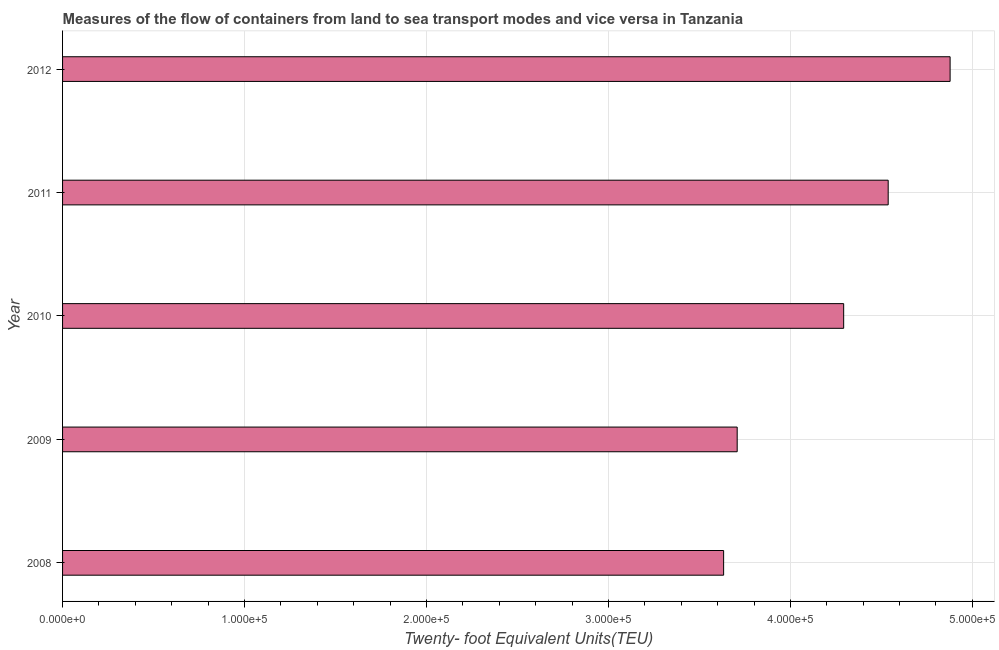Does the graph contain any zero values?
Ensure brevity in your answer.  No. Does the graph contain grids?
Offer a very short reply. Yes. What is the title of the graph?
Provide a short and direct response. Measures of the flow of containers from land to sea transport modes and vice versa in Tanzania. What is the label or title of the X-axis?
Your response must be concise. Twenty- foot Equivalent Units(TEU). What is the label or title of the Y-axis?
Your answer should be very brief. Year. What is the container port traffic in 2011?
Provide a succinct answer. 4.54e+05. Across all years, what is the maximum container port traffic?
Offer a terse response. 4.88e+05. Across all years, what is the minimum container port traffic?
Keep it short and to the point. 3.63e+05. In which year was the container port traffic maximum?
Provide a succinct answer. 2012. In which year was the container port traffic minimum?
Your response must be concise. 2008. What is the sum of the container port traffic?
Keep it short and to the point. 2.10e+06. What is the difference between the container port traffic in 2010 and 2011?
Offer a very short reply. -2.45e+04. What is the average container port traffic per year?
Your answer should be very brief. 4.21e+05. What is the median container port traffic?
Make the answer very short. 4.29e+05. In how many years, is the container port traffic greater than 300000 TEU?
Ensure brevity in your answer.  5. Do a majority of the years between 2009 and 2010 (inclusive) have container port traffic greater than 160000 TEU?
Your answer should be compact. Yes. What is the ratio of the container port traffic in 2009 to that in 2010?
Make the answer very short. 0.86. Is the container port traffic in 2009 less than that in 2010?
Ensure brevity in your answer.  Yes. What is the difference between the highest and the second highest container port traffic?
Your answer should be compact. 3.40e+04. Is the sum of the container port traffic in 2009 and 2012 greater than the maximum container port traffic across all years?
Your response must be concise. Yes. What is the difference between the highest and the lowest container port traffic?
Provide a short and direct response. 1.24e+05. In how many years, is the container port traffic greater than the average container port traffic taken over all years?
Offer a very short reply. 3. What is the difference between two consecutive major ticks on the X-axis?
Provide a succinct answer. 1.00e+05. Are the values on the major ticks of X-axis written in scientific E-notation?
Your response must be concise. Yes. What is the Twenty- foot Equivalent Units(TEU) of 2008?
Offer a very short reply. 3.63e+05. What is the Twenty- foot Equivalent Units(TEU) of 2009?
Keep it short and to the point. 3.71e+05. What is the Twenty- foot Equivalent Units(TEU) in 2010?
Offer a very short reply. 4.29e+05. What is the Twenty- foot Equivalent Units(TEU) of 2011?
Offer a very short reply. 4.54e+05. What is the Twenty- foot Equivalent Units(TEU) in 2012?
Ensure brevity in your answer.  4.88e+05. What is the difference between the Twenty- foot Equivalent Units(TEU) in 2008 and 2009?
Make the answer very short. -7454.7. What is the difference between the Twenty- foot Equivalent Units(TEU) in 2008 and 2010?
Your answer should be compact. -6.60e+04. What is the difference between the Twenty- foot Equivalent Units(TEU) in 2008 and 2011?
Give a very brief answer. -9.04e+04. What is the difference between the Twenty- foot Equivalent Units(TEU) in 2008 and 2012?
Your answer should be compact. -1.24e+05. What is the difference between the Twenty- foot Equivalent Units(TEU) in 2009 and 2010?
Keep it short and to the point. -5.85e+04. What is the difference between the Twenty- foot Equivalent Units(TEU) in 2009 and 2011?
Give a very brief answer. -8.30e+04. What is the difference between the Twenty- foot Equivalent Units(TEU) in 2009 and 2012?
Give a very brief answer. -1.17e+05. What is the difference between the Twenty- foot Equivalent Units(TEU) in 2010 and 2011?
Your answer should be compact. -2.45e+04. What is the difference between the Twenty- foot Equivalent Units(TEU) in 2010 and 2012?
Offer a very short reply. -5.85e+04. What is the difference between the Twenty- foot Equivalent Units(TEU) in 2011 and 2012?
Your response must be concise. -3.40e+04. What is the ratio of the Twenty- foot Equivalent Units(TEU) in 2008 to that in 2009?
Keep it short and to the point. 0.98. What is the ratio of the Twenty- foot Equivalent Units(TEU) in 2008 to that in 2010?
Keep it short and to the point. 0.85. What is the ratio of the Twenty- foot Equivalent Units(TEU) in 2008 to that in 2011?
Your answer should be very brief. 0.8. What is the ratio of the Twenty- foot Equivalent Units(TEU) in 2008 to that in 2012?
Give a very brief answer. 0.74. What is the ratio of the Twenty- foot Equivalent Units(TEU) in 2009 to that in 2010?
Provide a succinct answer. 0.86. What is the ratio of the Twenty- foot Equivalent Units(TEU) in 2009 to that in 2011?
Keep it short and to the point. 0.82. What is the ratio of the Twenty- foot Equivalent Units(TEU) in 2009 to that in 2012?
Provide a succinct answer. 0.76. What is the ratio of the Twenty- foot Equivalent Units(TEU) in 2010 to that in 2011?
Your response must be concise. 0.95. What is the ratio of the Twenty- foot Equivalent Units(TEU) in 2010 to that in 2012?
Offer a terse response. 0.88. 